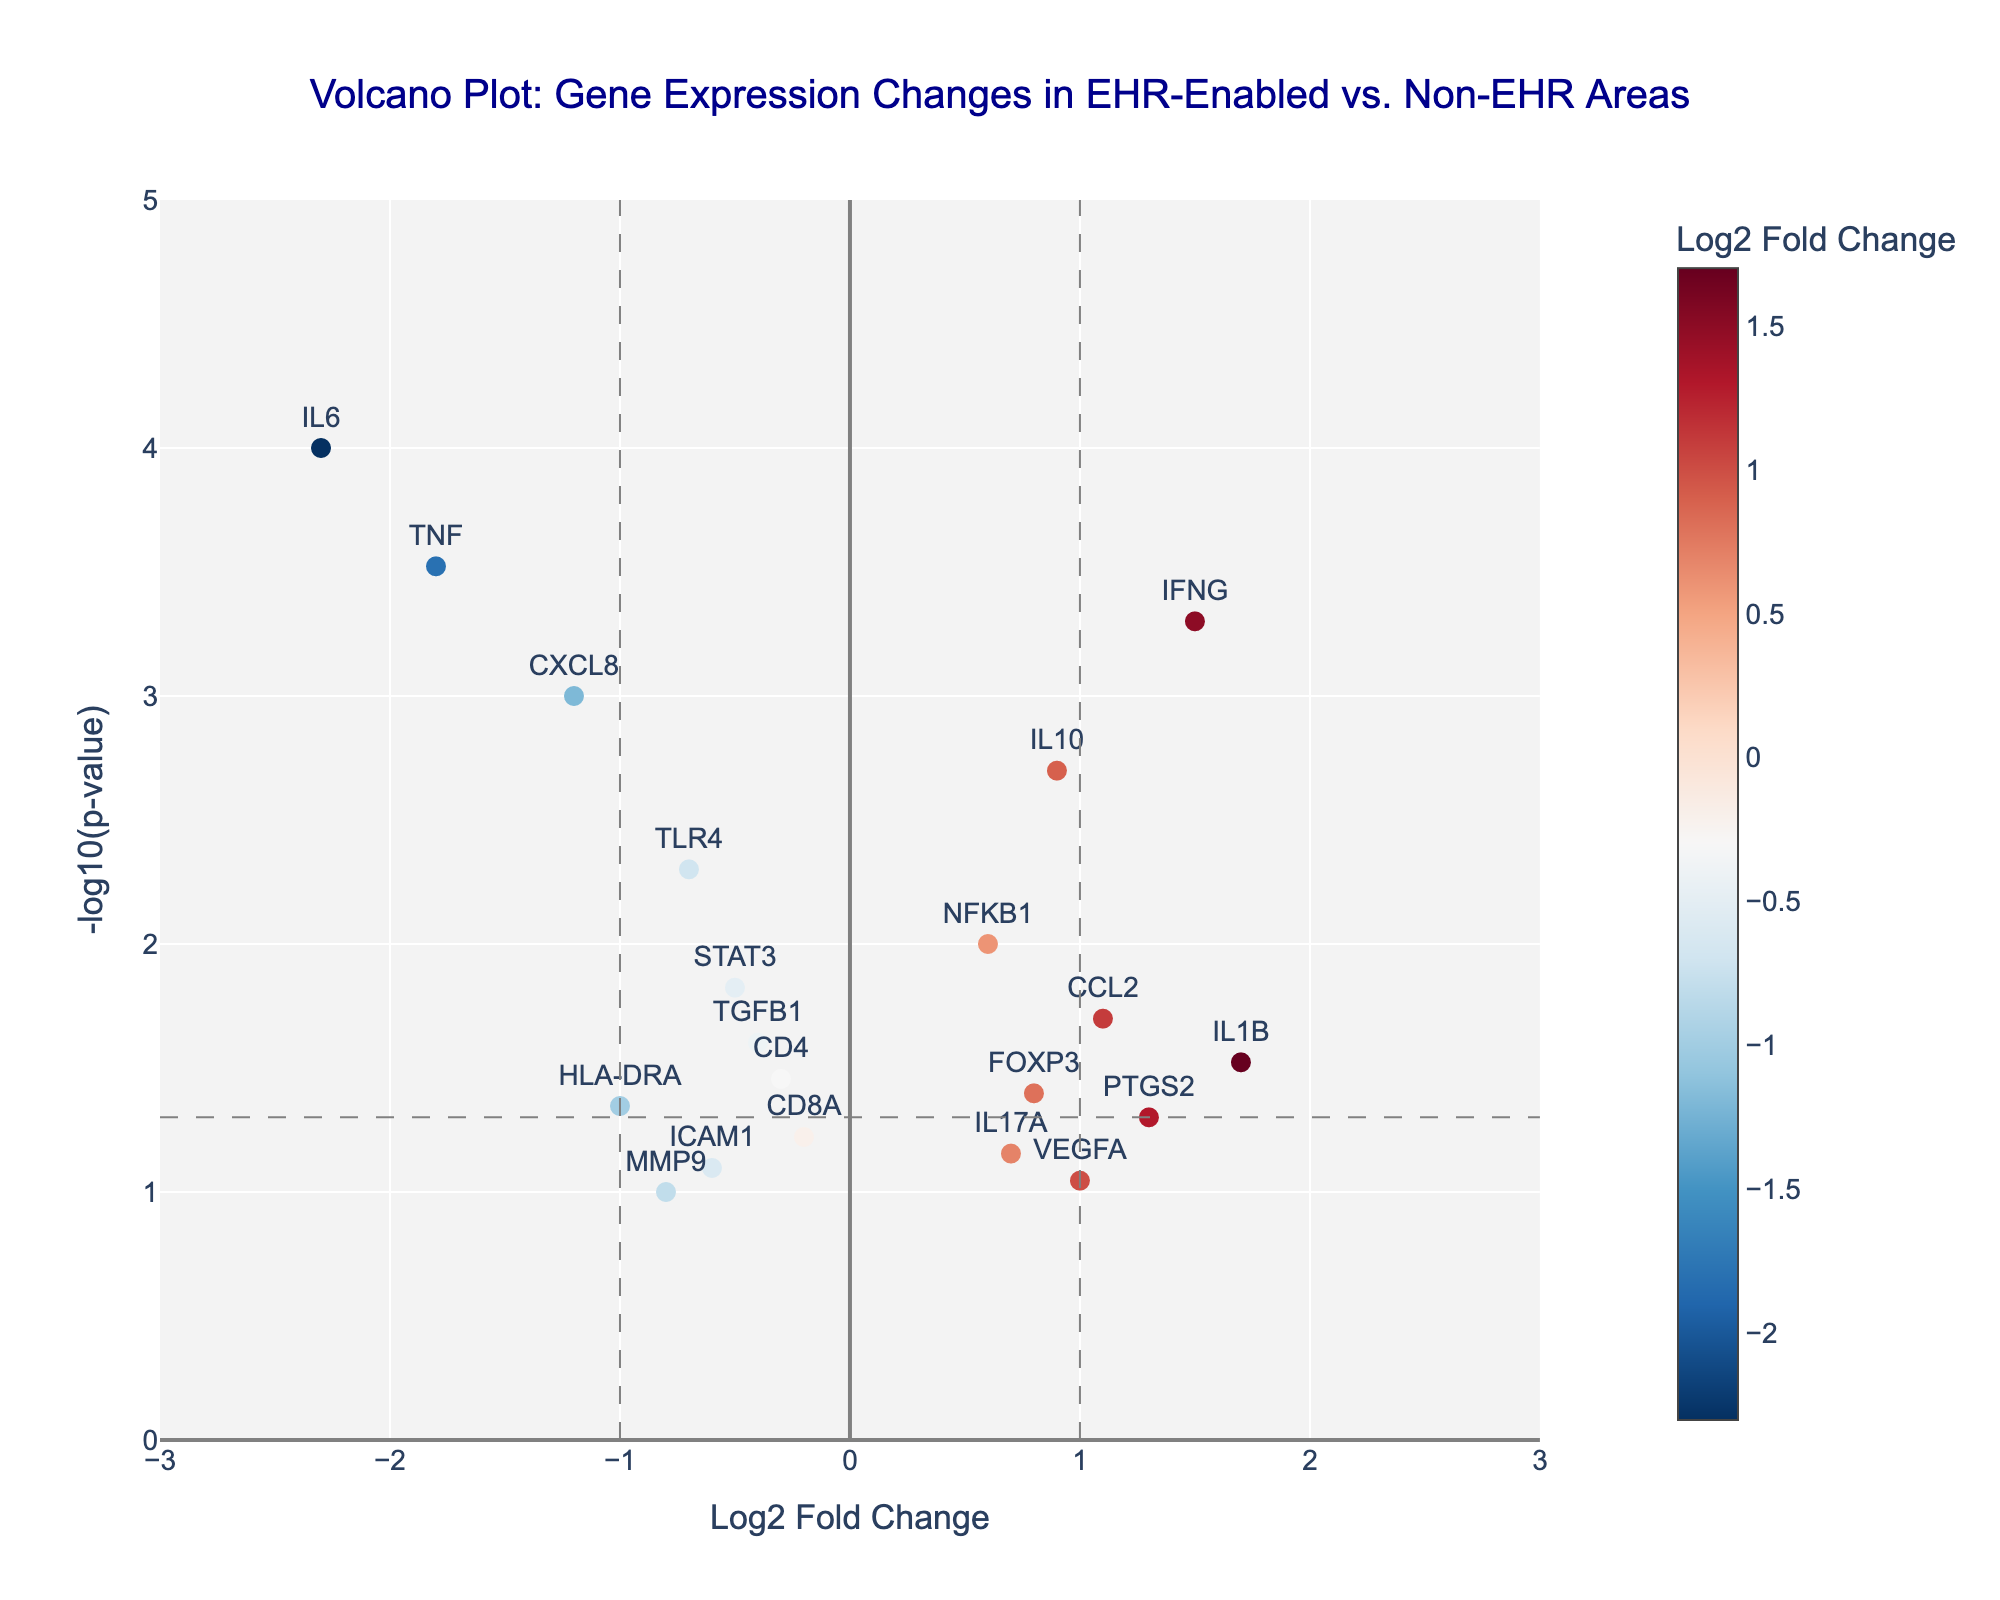What is the title of the plot? The title is placed at the top and centered. It reads "Volcano Plot: Gene Expression Changes in EHR-Enabled vs. Non-EHR Areas".
Answer: Volcano Plot: Gene Expression Changes in EHR-Enabled vs. Non-EHR Areas Which gene has the most significant negative log2 fold change? Look for the point farthest to the left and check the annotated gene label. The gene farthest to the left is IL6.
Answer: IL6 How many genes have a p-value less than 0.05? Count the data points that are above the horizontal line representing -log10(p-value) of 0.05. There are 10 such points.
Answer: 10 Which gene has the highest -log10(p-value)? Identify the point with the highest y-axis value and read the annotated gene label. The gene with the highest -log10(p-value) is IL6.
Answer: IL6 Is there any gene with a log2 fold change greater than 1 that is also statistically significant (p-value < 0.05)? Identify points with x-coordinate greater than 1 and y-coordinate above the horizontal line at -log10(0.05). The gene IFNG meets this criterion.
Answer: IFNG Which gene has a log2 fold change closest to zero but is still statistically significant? Look for the point closest to the y-axis (x=0) that also lies above the horizontal significance threshold line. The gene STAT3 fits this description.
Answer: STAT3 What color represents genes with positive log2 fold change values? The colors represented along the color bar for positive log2 fold changes range from light blue to red.
Answer: Light blue to red Of the genes with a log2 fold change less than -1, which has the smallest p-value? Among the points to the left of -1, find the one highest on the y-axis (smallest p-value). The gene IL6 fits this criterion.
Answer: IL6 What is the log2 fold change of VEGFA? Locate the point labeled VEGFA and check its x-coordinate value. VEGFA has a log2 fold change of 1.0.
Answer: 1.0 Are there more genes with a positive or negative log2 fold change that are statistically significant? Count the number of genes above the horizontal line at -log10(0.05) with positive log2 fold change and compare with those with negative log2 fold change. There are 4 statistically significant positive FC genes (IFNG, IL10, NFKB1, CCL2) and 6 statistically significant negative FC genes (IL6, TNF, CXCL8, TLR4, HLA-DRA, PTGS2).
Answer: Negative 